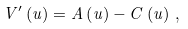Convert formula to latex. <formula><loc_0><loc_0><loc_500><loc_500>V ^ { \prime } \left ( u \right ) = A \left ( u \right ) - C \left ( u \right ) \, ,</formula> 